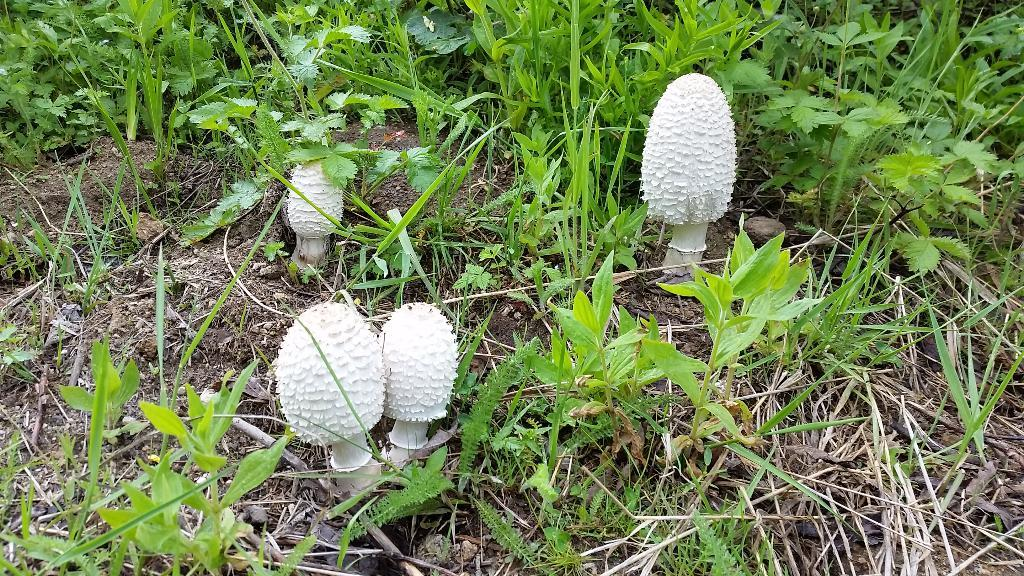What type of fungi can be seen in the image? There are mushrooms in the image. What other living organisms are present in the image? There are plants in the image. What type of quartz is used as a boundary in the image? There is no quartz or boundary present in the image; it features mushrooms and plants. What type of stew is being prepared in the image? There is no stew or cooking activity present in the image. 